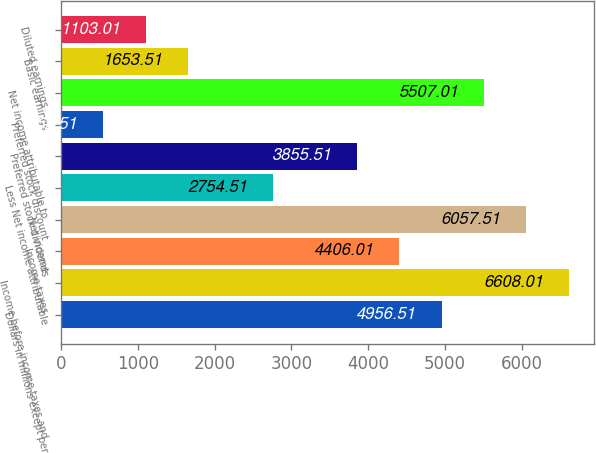Convert chart. <chart><loc_0><loc_0><loc_500><loc_500><bar_chart><fcel>Dollars in millions except per<fcel>Income before income taxes and<fcel>Income taxes<fcel>Net income<fcel>Less Net income attributable<fcel>Preferred stock dividends<fcel>Preferred stock discount<fcel>Net income attributable to<fcel>Basic earnings<fcel>Diluted earnings<nl><fcel>4956.51<fcel>6608.01<fcel>4406.01<fcel>6057.51<fcel>2754.51<fcel>3855.51<fcel>552.51<fcel>5507.01<fcel>1653.51<fcel>1103.01<nl></chart> 